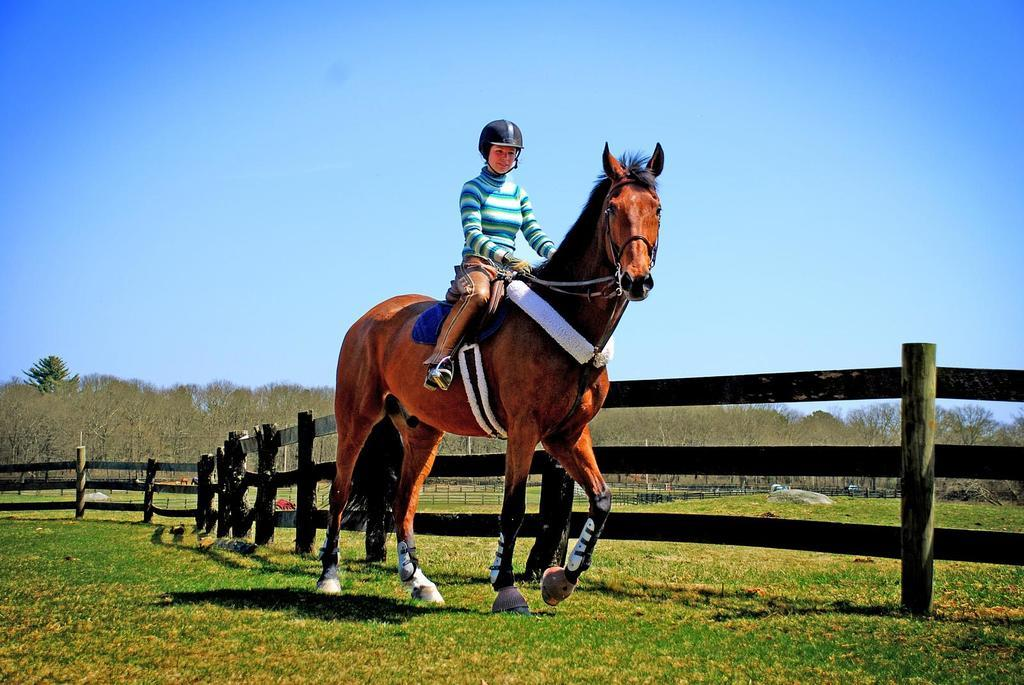What is the main subject of the image? There is a person sitting on a horse in the image. What is the horse standing on? The horse is on a greenery ground. What is located beside the horse? There is a fence beside the horse. What can be seen in the background of the image? There are trees in the background of the image. What type of thread is being used to create the shade in the image? There is no shade or thread present in the image. 